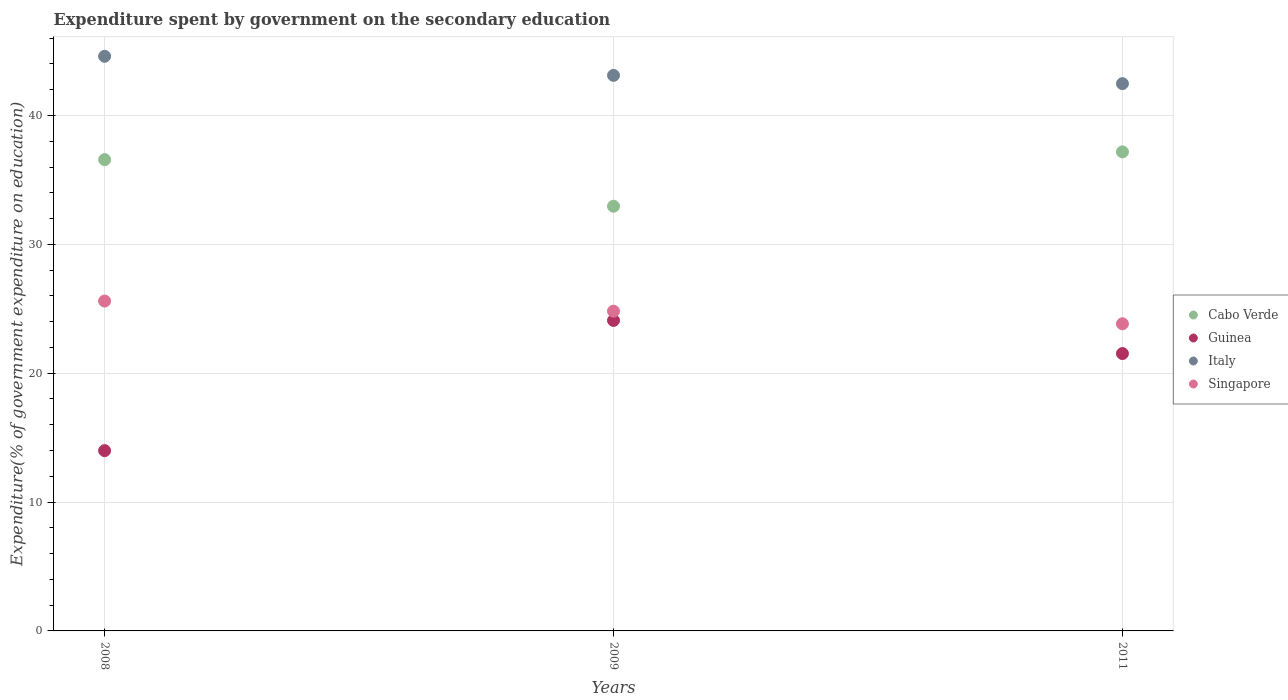Is the number of dotlines equal to the number of legend labels?
Provide a short and direct response. Yes. What is the expenditure spent by government on the secondary education in Singapore in 2008?
Ensure brevity in your answer.  25.6. Across all years, what is the maximum expenditure spent by government on the secondary education in Cabo Verde?
Give a very brief answer. 37.17. Across all years, what is the minimum expenditure spent by government on the secondary education in Cabo Verde?
Offer a very short reply. 32.96. In which year was the expenditure spent by government on the secondary education in Singapore minimum?
Your answer should be very brief. 2011. What is the total expenditure spent by government on the secondary education in Cabo Verde in the graph?
Make the answer very short. 106.71. What is the difference between the expenditure spent by government on the secondary education in Singapore in 2008 and that in 2009?
Ensure brevity in your answer.  0.79. What is the difference between the expenditure spent by government on the secondary education in Singapore in 2011 and the expenditure spent by government on the secondary education in Italy in 2009?
Provide a succinct answer. -19.28. What is the average expenditure spent by government on the secondary education in Guinea per year?
Give a very brief answer. 19.87. In the year 2009, what is the difference between the expenditure spent by government on the secondary education in Italy and expenditure spent by government on the secondary education in Singapore?
Give a very brief answer. 18.3. In how many years, is the expenditure spent by government on the secondary education in Italy greater than 20 %?
Give a very brief answer. 3. What is the ratio of the expenditure spent by government on the secondary education in Singapore in 2008 to that in 2011?
Your answer should be compact. 1.07. What is the difference between the highest and the second highest expenditure spent by government on the secondary education in Guinea?
Offer a terse response. 2.57. What is the difference between the highest and the lowest expenditure spent by government on the secondary education in Cabo Verde?
Make the answer very short. 4.22. Is it the case that in every year, the sum of the expenditure spent by government on the secondary education in Italy and expenditure spent by government on the secondary education in Singapore  is greater than the sum of expenditure spent by government on the secondary education in Guinea and expenditure spent by government on the secondary education in Cabo Verde?
Make the answer very short. Yes. Is it the case that in every year, the sum of the expenditure spent by government on the secondary education in Cabo Verde and expenditure spent by government on the secondary education in Guinea  is greater than the expenditure spent by government on the secondary education in Singapore?
Your answer should be very brief. Yes. How many dotlines are there?
Your response must be concise. 4. How many years are there in the graph?
Keep it short and to the point. 3. Are the values on the major ticks of Y-axis written in scientific E-notation?
Your answer should be very brief. No. Does the graph contain any zero values?
Provide a short and direct response. No. Does the graph contain grids?
Your answer should be compact. Yes. Where does the legend appear in the graph?
Make the answer very short. Center right. What is the title of the graph?
Offer a very short reply. Expenditure spent by government on the secondary education. What is the label or title of the Y-axis?
Provide a short and direct response. Expenditure(% of government expenditure on education). What is the Expenditure(% of government expenditure on education) of Cabo Verde in 2008?
Keep it short and to the point. 36.57. What is the Expenditure(% of government expenditure on education) in Guinea in 2008?
Offer a very short reply. 13.99. What is the Expenditure(% of government expenditure on education) in Italy in 2008?
Keep it short and to the point. 44.59. What is the Expenditure(% of government expenditure on education) of Singapore in 2008?
Give a very brief answer. 25.6. What is the Expenditure(% of government expenditure on education) of Cabo Verde in 2009?
Provide a succinct answer. 32.96. What is the Expenditure(% of government expenditure on education) in Guinea in 2009?
Give a very brief answer. 24.09. What is the Expenditure(% of government expenditure on education) in Italy in 2009?
Provide a short and direct response. 43.11. What is the Expenditure(% of government expenditure on education) in Singapore in 2009?
Your answer should be compact. 24.81. What is the Expenditure(% of government expenditure on education) of Cabo Verde in 2011?
Your answer should be compact. 37.17. What is the Expenditure(% of government expenditure on education) of Guinea in 2011?
Offer a very short reply. 21.52. What is the Expenditure(% of government expenditure on education) of Italy in 2011?
Ensure brevity in your answer.  42.47. What is the Expenditure(% of government expenditure on education) in Singapore in 2011?
Your response must be concise. 23.83. Across all years, what is the maximum Expenditure(% of government expenditure on education) in Cabo Verde?
Provide a short and direct response. 37.17. Across all years, what is the maximum Expenditure(% of government expenditure on education) of Guinea?
Give a very brief answer. 24.09. Across all years, what is the maximum Expenditure(% of government expenditure on education) in Italy?
Offer a terse response. 44.59. Across all years, what is the maximum Expenditure(% of government expenditure on education) in Singapore?
Keep it short and to the point. 25.6. Across all years, what is the minimum Expenditure(% of government expenditure on education) of Cabo Verde?
Offer a very short reply. 32.96. Across all years, what is the minimum Expenditure(% of government expenditure on education) of Guinea?
Give a very brief answer. 13.99. Across all years, what is the minimum Expenditure(% of government expenditure on education) of Italy?
Your answer should be very brief. 42.47. Across all years, what is the minimum Expenditure(% of government expenditure on education) in Singapore?
Your answer should be compact. 23.83. What is the total Expenditure(% of government expenditure on education) in Cabo Verde in the graph?
Give a very brief answer. 106.71. What is the total Expenditure(% of government expenditure on education) of Guinea in the graph?
Provide a short and direct response. 59.61. What is the total Expenditure(% of government expenditure on education) of Italy in the graph?
Provide a succinct answer. 130.18. What is the total Expenditure(% of government expenditure on education) of Singapore in the graph?
Provide a succinct answer. 74.25. What is the difference between the Expenditure(% of government expenditure on education) of Cabo Verde in 2008 and that in 2009?
Give a very brief answer. 3.62. What is the difference between the Expenditure(% of government expenditure on education) in Guinea in 2008 and that in 2009?
Your answer should be compact. -10.1. What is the difference between the Expenditure(% of government expenditure on education) of Italy in 2008 and that in 2009?
Provide a short and direct response. 1.48. What is the difference between the Expenditure(% of government expenditure on education) of Singapore in 2008 and that in 2009?
Give a very brief answer. 0.79. What is the difference between the Expenditure(% of government expenditure on education) in Cabo Verde in 2008 and that in 2011?
Give a very brief answer. -0.6. What is the difference between the Expenditure(% of government expenditure on education) of Guinea in 2008 and that in 2011?
Make the answer very short. -7.53. What is the difference between the Expenditure(% of government expenditure on education) of Italy in 2008 and that in 2011?
Give a very brief answer. 2.12. What is the difference between the Expenditure(% of government expenditure on education) of Singapore in 2008 and that in 2011?
Your response must be concise. 1.77. What is the difference between the Expenditure(% of government expenditure on education) of Cabo Verde in 2009 and that in 2011?
Offer a very short reply. -4.22. What is the difference between the Expenditure(% of government expenditure on education) in Guinea in 2009 and that in 2011?
Your answer should be compact. 2.57. What is the difference between the Expenditure(% of government expenditure on education) of Italy in 2009 and that in 2011?
Your response must be concise. 0.64. What is the difference between the Expenditure(% of government expenditure on education) in Singapore in 2009 and that in 2011?
Your response must be concise. 0.98. What is the difference between the Expenditure(% of government expenditure on education) of Cabo Verde in 2008 and the Expenditure(% of government expenditure on education) of Guinea in 2009?
Provide a succinct answer. 12.48. What is the difference between the Expenditure(% of government expenditure on education) in Cabo Verde in 2008 and the Expenditure(% of government expenditure on education) in Italy in 2009?
Make the answer very short. -6.54. What is the difference between the Expenditure(% of government expenditure on education) in Cabo Verde in 2008 and the Expenditure(% of government expenditure on education) in Singapore in 2009?
Keep it short and to the point. 11.76. What is the difference between the Expenditure(% of government expenditure on education) of Guinea in 2008 and the Expenditure(% of government expenditure on education) of Italy in 2009?
Your answer should be very brief. -29.12. What is the difference between the Expenditure(% of government expenditure on education) in Guinea in 2008 and the Expenditure(% of government expenditure on education) in Singapore in 2009?
Provide a short and direct response. -10.82. What is the difference between the Expenditure(% of government expenditure on education) in Italy in 2008 and the Expenditure(% of government expenditure on education) in Singapore in 2009?
Offer a very short reply. 19.78. What is the difference between the Expenditure(% of government expenditure on education) in Cabo Verde in 2008 and the Expenditure(% of government expenditure on education) in Guinea in 2011?
Offer a very short reply. 15.05. What is the difference between the Expenditure(% of government expenditure on education) in Cabo Verde in 2008 and the Expenditure(% of government expenditure on education) in Italy in 2011?
Ensure brevity in your answer.  -5.9. What is the difference between the Expenditure(% of government expenditure on education) of Cabo Verde in 2008 and the Expenditure(% of government expenditure on education) of Singapore in 2011?
Keep it short and to the point. 12.74. What is the difference between the Expenditure(% of government expenditure on education) in Guinea in 2008 and the Expenditure(% of government expenditure on education) in Italy in 2011?
Provide a short and direct response. -28.48. What is the difference between the Expenditure(% of government expenditure on education) of Guinea in 2008 and the Expenditure(% of government expenditure on education) of Singapore in 2011?
Your response must be concise. -9.84. What is the difference between the Expenditure(% of government expenditure on education) in Italy in 2008 and the Expenditure(% of government expenditure on education) in Singapore in 2011?
Your response must be concise. 20.76. What is the difference between the Expenditure(% of government expenditure on education) of Cabo Verde in 2009 and the Expenditure(% of government expenditure on education) of Guinea in 2011?
Provide a short and direct response. 11.43. What is the difference between the Expenditure(% of government expenditure on education) of Cabo Verde in 2009 and the Expenditure(% of government expenditure on education) of Italy in 2011?
Keep it short and to the point. -9.51. What is the difference between the Expenditure(% of government expenditure on education) in Cabo Verde in 2009 and the Expenditure(% of government expenditure on education) in Singapore in 2011?
Offer a very short reply. 9.12. What is the difference between the Expenditure(% of government expenditure on education) in Guinea in 2009 and the Expenditure(% of government expenditure on education) in Italy in 2011?
Your answer should be compact. -18.38. What is the difference between the Expenditure(% of government expenditure on education) in Guinea in 2009 and the Expenditure(% of government expenditure on education) in Singapore in 2011?
Offer a terse response. 0.26. What is the difference between the Expenditure(% of government expenditure on education) of Italy in 2009 and the Expenditure(% of government expenditure on education) of Singapore in 2011?
Your answer should be compact. 19.28. What is the average Expenditure(% of government expenditure on education) of Cabo Verde per year?
Your answer should be very brief. 35.57. What is the average Expenditure(% of government expenditure on education) in Guinea per year?
Provide a short and direct response. 19.87. What is the average Expenditure(% of government expenditure on education) of Italy per year?
Your answer should be very brief. 43.39. What is the average Expenditure(% of government expenditure on education) in Singapore per year?
Provide a succinct answer. 24.75. In the year 2008, what is the difference between the Expenditure(% of government expenditure on education) of Cabo Verde and Expenditure(% of government expenditure on education) of Guinea?
Provide a succinct answer. 22.58. In the year 2008, what is the difference between the Expenditure(% of government expenditure on education) in Cabo Verde and Expenditure(% of government expenditure on education) in Italy?
Offer a terse response. -8.02. In the year 2008, what is the difference between the Expenditure(% of government expenditure on education) in Cabo Verde and Expenditure(% of government expenditure on education) in Singapore?
Provide a succinct answer. 10.97. In the year 2008, what is the difference between the Expenditure(% of government expenditure on education) of Guinea and Expenditure(% of government expenditure on education) of Italy?
Provide a succinct answer. -30.6. In the year 2008, what is the difference between the Expenditure(% of government expenditure on education) of Guinea and Expenditure(% of government expenditure on education) of Singapore?
Provide a short and direct response. -11.61. In the year 2008, what is the difference between the Expenditure(% of government expenditure on education) of Italy and Expenditure(% of government expenditure on education) of Singapore?
Provide a succinct answer. 18.99. In the year 2009, what is the difference between the Expenditure(% of government expenditure on education) of Cabo Verde and Expenditure(% of government expenditure on education) of Guinea?
Keep it short and to the point. 8.86. In the year 2009, what is the difference between the Expenditure(% of government expenditure on education) of Cabo Verde and Expenditure(% of government expenditure on education) of Italy?
Provide a succinct answer. -10.15. In the year 2009, what is the difference between the Expenditure(% of government expenditure on education) in Cabo Verde and Expenditure(% of government expenditure on education) in Singapore?
Your response must be concise. 8.15. In the year 2009, what is the difference between the Expenditure(% of government expenditure on education) of Guinea and Expenditure(% of government expenditure on education) of Italy?
Ensure brevity in your answer.  -19.02. In the year 2009, what is the difference between the Expenditure(% of government expenditure on education) in Guinea and Expenditure(% of government expenditure on education) in Singapore?
Make the answer very short. -0.72. In the year 2009, what is the difference between the Expenditure(% of government expenditure on education) of Italy and Expenditure(% of government expenditure on education) of Singapore?
Your response must be concise. 18.3. In the year 2011, what is the difference between the Expenditure(% of government expenditure on education) in Cabo Verde and Expenditure(% of government expenditure on education) in Guinea?
Keep it short and to the point. 15.65. In the year 2011, what is the difference between the Expenditure(% of government expenditure on education) in Cabo Verde and Expenditure(% of government expenditure on education) in Italy?
Ensure brevity in your answer.  -5.3. In the year 2011, what is the difference between the Expenditure(% of government expenditure on education) in Cabo Verde and Expenditure(% of government expenditure on education) in Singapore?
Offer a terse response. 13.34. In the year 2011, what is the difference between the Expenditure(% of government expenditure on education) in Guinea and Expenditure(% of government expenditure on education) in Italy?
Your answer should be compact. -20.95. In the year 2011, what is the difference between the Expenditure(% of government expenditure on education) of Guinea and Expenditure(% of government expenditure on education) of Singapore?
Your answer should be very brief. -2.31. In the year 2011, what is the difference between the Expenditure(% of government expenditure on education) of Italy and Expenditure(% of government expenditure on education) of Singapore?
Your response must be concise. 18.64. What is the ratio of the Expenditure(% of government expenditure on education) in Cabo Verde in 2008 to that in 2009?
Offer a terse response. 1.11. What is the ratio of the Expenditure(% of government expenditure on education) in Guinea in 2008 to that in 2009?
Keep it short and to the point. 0.58. What is the ratio of the Expenditure(% of government expenditure on education) of Italy in 2008 to that in 2009?
Your response must be concise. 1.03. What is the ratio of the Expenditure(% of government expenditure on education) in Singapore in 2008 to that in 2009?
Your answer should be compact. 1.03. What is the ratio of the Expenditure(% of government expenditure on education) of Cabo Verde in 2008 to that in 2011?
Provide a succinct answer. 0.98. What is the ratio of the Expenditure(% of government expenditure on education) of Guinea in 2008 to that in 2011?
Provide a short and direct response. 0.65. What is the ratio of the Expenditure(% of government expenditure on education) of Singapore in 2008 to that in 2011?
Make the answer very short. 1.07. What is the ratio of the Expenditure(% of government expenditure on education) of Cabo Verde in 2009 to that in 2011?
Offer a terse response. 0.89. What is the ratio of the Expenditure(% of government expenditure on education) of Guinea in 2009 to that in 2011?
Make the answer very short. 1.12. What is the ratio of the Expenditure(% of government expenditure on education) in Italy in 2009 to that in 2011?
Keep it short and to the point. 1.02. What is the ratio of the Expenditure(% of government expenditure on education) of Singapore in 2009 to that in 2011?
Offer a terse response. 1.04. What is the difference between the highest and the second highest Expenditure(% of government expenditure on education) of Cabo Verde?
Your answer should be compact. 0.6. What is the difference between the highest and the second highest Expenditure(% of government expenditure on education) in Guinea?
Offer a very short reply. 2.57. What is the difference between the highest and the second highest Expenditure(% of government expenditure on education) in Italy?
Make the answer very short. 1.48. What is the difference between the highest and the second highest Expenditure(% of government expenditure on education) in Singapore?
Ensure brevity in your answer.  0.79. What is the difference between the highest and the lowest Expenditure(% of government expenditure on education) of Cabo Verde?
Your response must be concise. 4.22. What is the difference between the highest and the lowest Expenditure(% of government expenditure on education) of Guinea?
Ensure brevity in your answer.  10.1. What is the difference between the highest and the lowest Expenditure(% of government expenditure on education) of Italy?
Your answer should be compact. 2.12. What is the difference between the highest and the lowest Expenditure(% of government expenditure on education) of Singapore?
Your answer should be very brief. 1.77. 